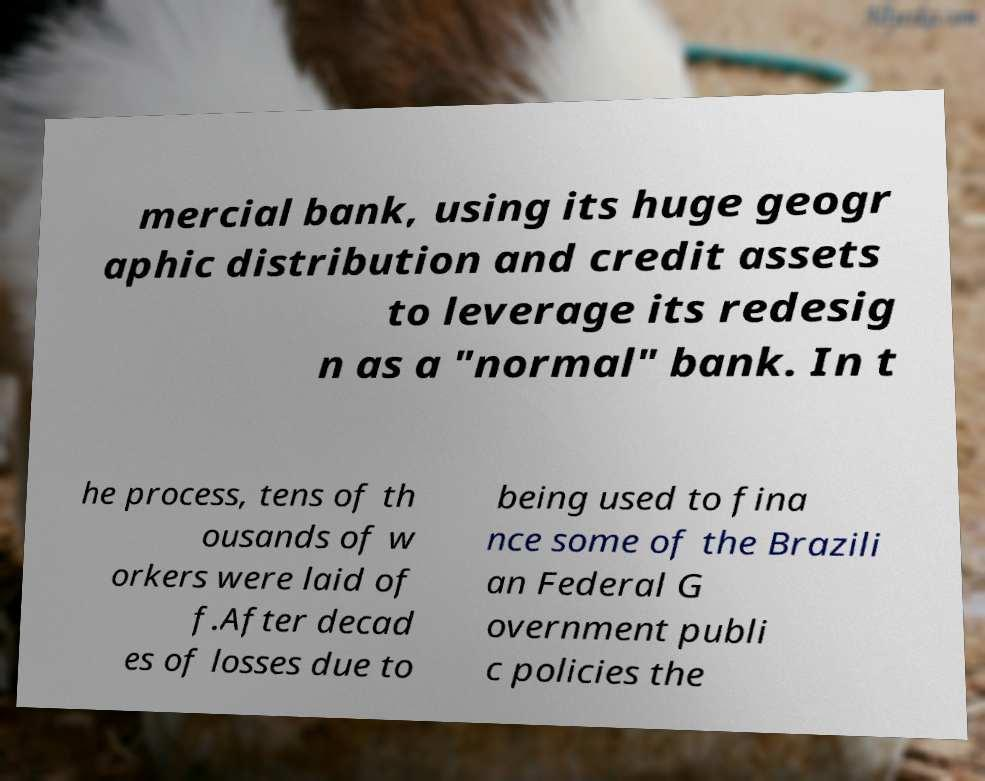There's text embedded in this image that I need extracted. Can you transcribe it verbatim? mercial bank, using its huge geogr aphic distribution and credit assets to leverage its redesig n as a "normal" bank. In t he process, tens of th ousands of w orkers were laid of f.After decad es of losses due to being used to fina nce some of the Brazili an Federal G overnment publi c policies the 